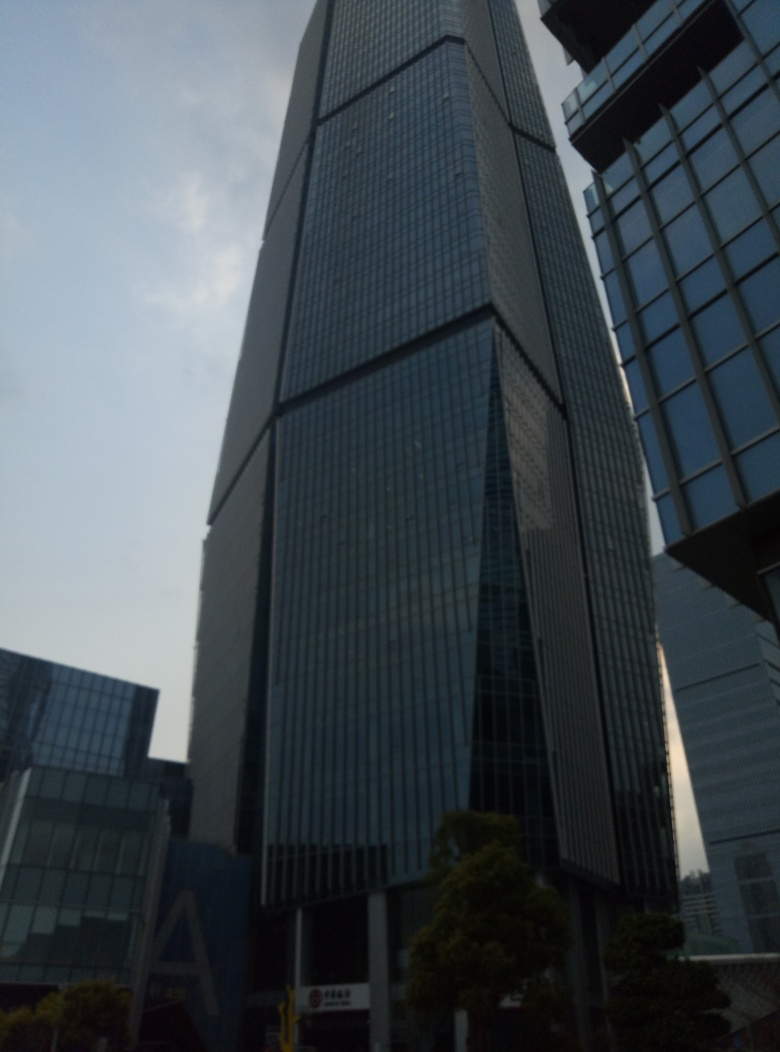Are there any quality issues with this image? Yes, there are several quality issues with this image. The lighting conditions are subpar, leading to an underexposed photograph with muted colors. The angle at which the photo was taken is not entirely straight, giving an off-balance feeling to the scene. Additionally, there's noticeable blur which might be due to camera shake or a moving subject. Lastly, the image lacks sharpness, limiting the clarity and detail of the architectural features. 